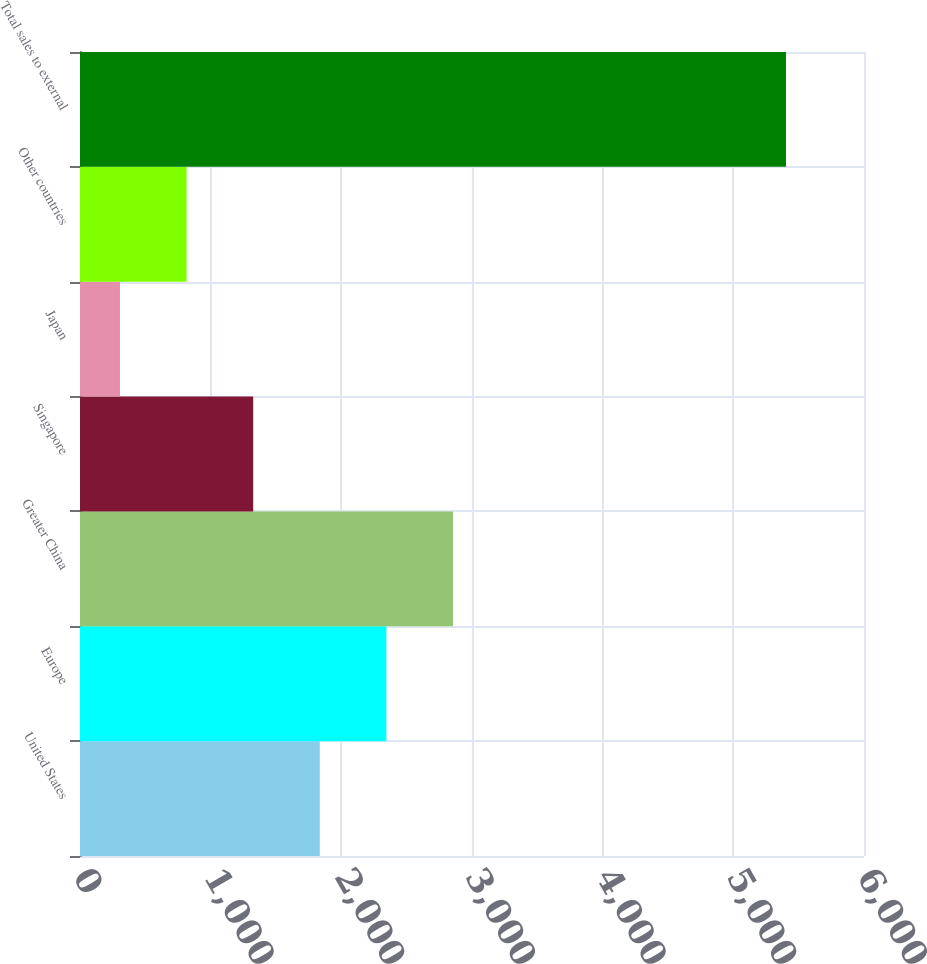Convert chart. <chart><loc_0><loc_0><loc_500><loc_500><bar_chart><fcel>United States<fcel>Europe<fcel>Greater China<fcel>Singapore<fcel>Japan<fcel>Other countries<fcel>Total sales to external<nl><fcel>1835.1<fcel>2344.8<fcel>2854.5<fcel>1325.4<fcel>306<fcel>815.7<fcel>5403<nl></chart> 